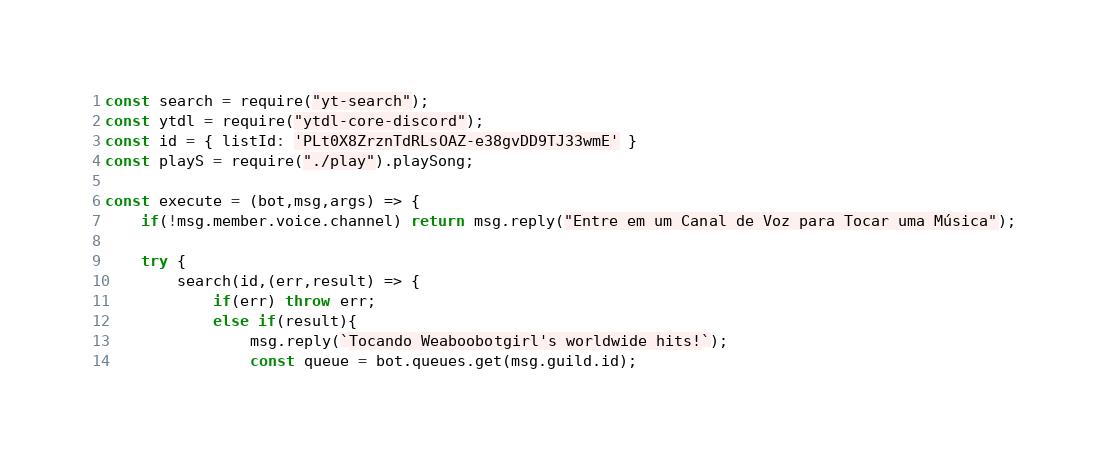Convert code to text. <code><loc_0><loc_0><loc_500><loc_500><_JavaScript_>const search = require("yt-search");
const ytdl = require("ytdl-core-discord");
const id = { listId: 'PLt0X8ZrznTdRLsOAZ-e38gvDD9TJ33wmE' }
const playS = require("./play").playSong;

const execute = (bot,msg,args) => {
    if(!msg.member.voice.channel) return msg.reply("Entre em um Canal de Voz para Tocar uma Música");

    try {
        search(id,(err,result) => {
            if(err) throw err;
            else if(result){
                msg.reply(`Tocando Weaboobotgirl's worldwide hits!`);
                const queue = bot.queues.get(msg.guild.id);</code> 